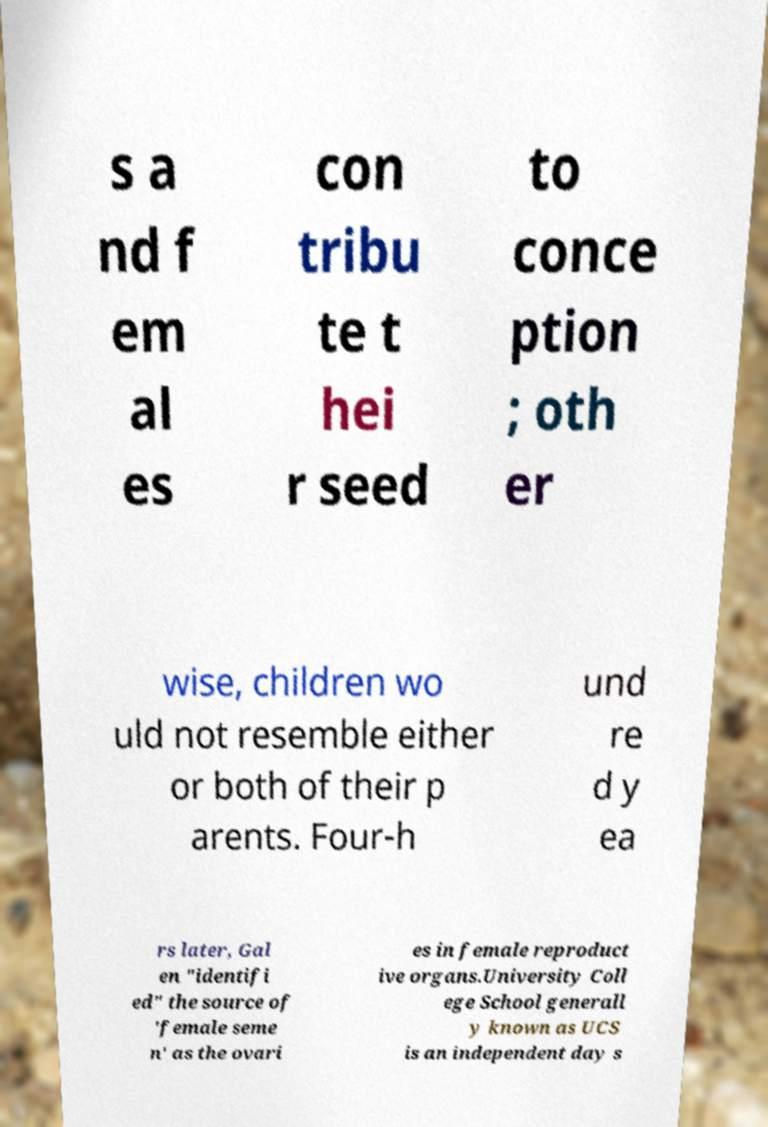Can you accurately transcribe the text from the provided image for me? s a nd f em al es con tribu te t hei r seed to conce ption ; oth er wise, children wo uld not resemble either or both of their p arents. Four-h und re d y ea rs later, Gal en "identifi ed" the source of 'female seme n' as the ovari es in female reproduct ive organs.University Coll ege School generall y known as UCS is an independent day s 